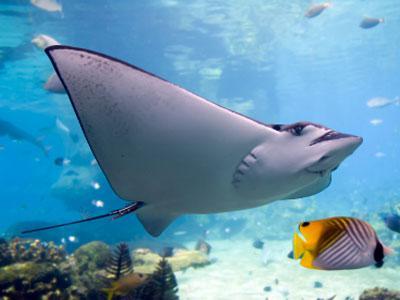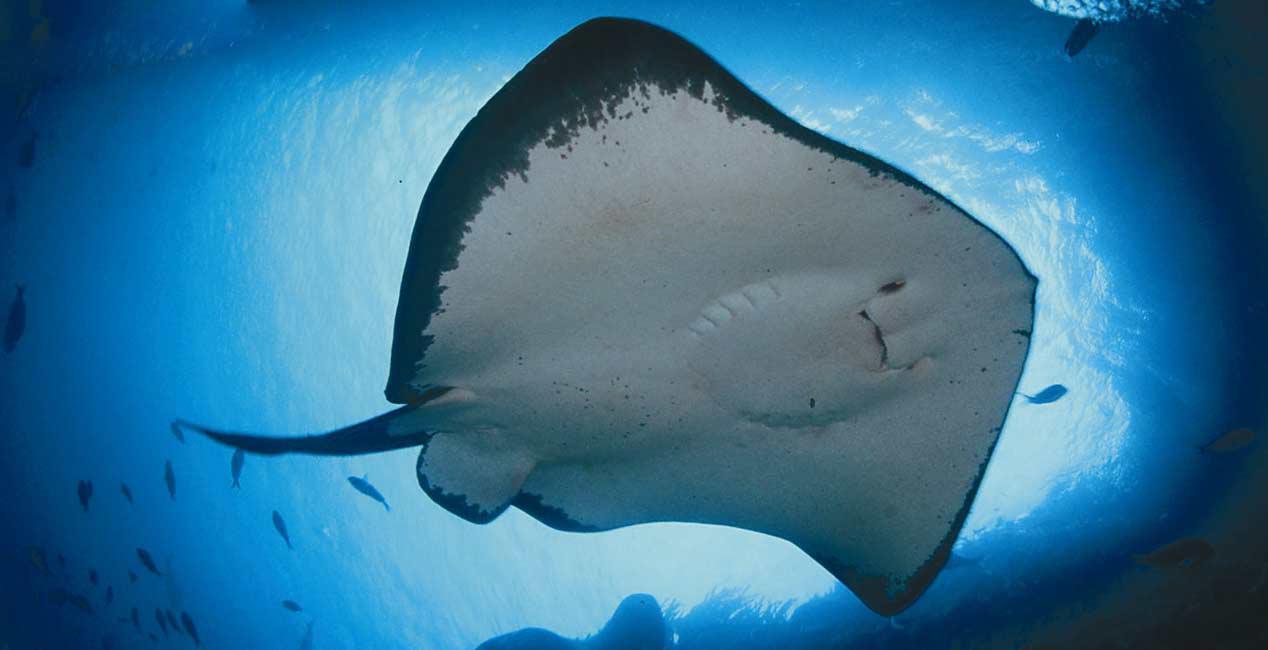The first image is the image on the left, the second image is the image on the right. Considering the images on both sides, is "One image in the pair has a human." valid? Answer yes or no. No. The first image is the image on the left, the second image is the image on the right. Assess this claim about the two images: "One image shows at least one person in the water with a stingray.". Correct or not? Answer yes or no. No. 